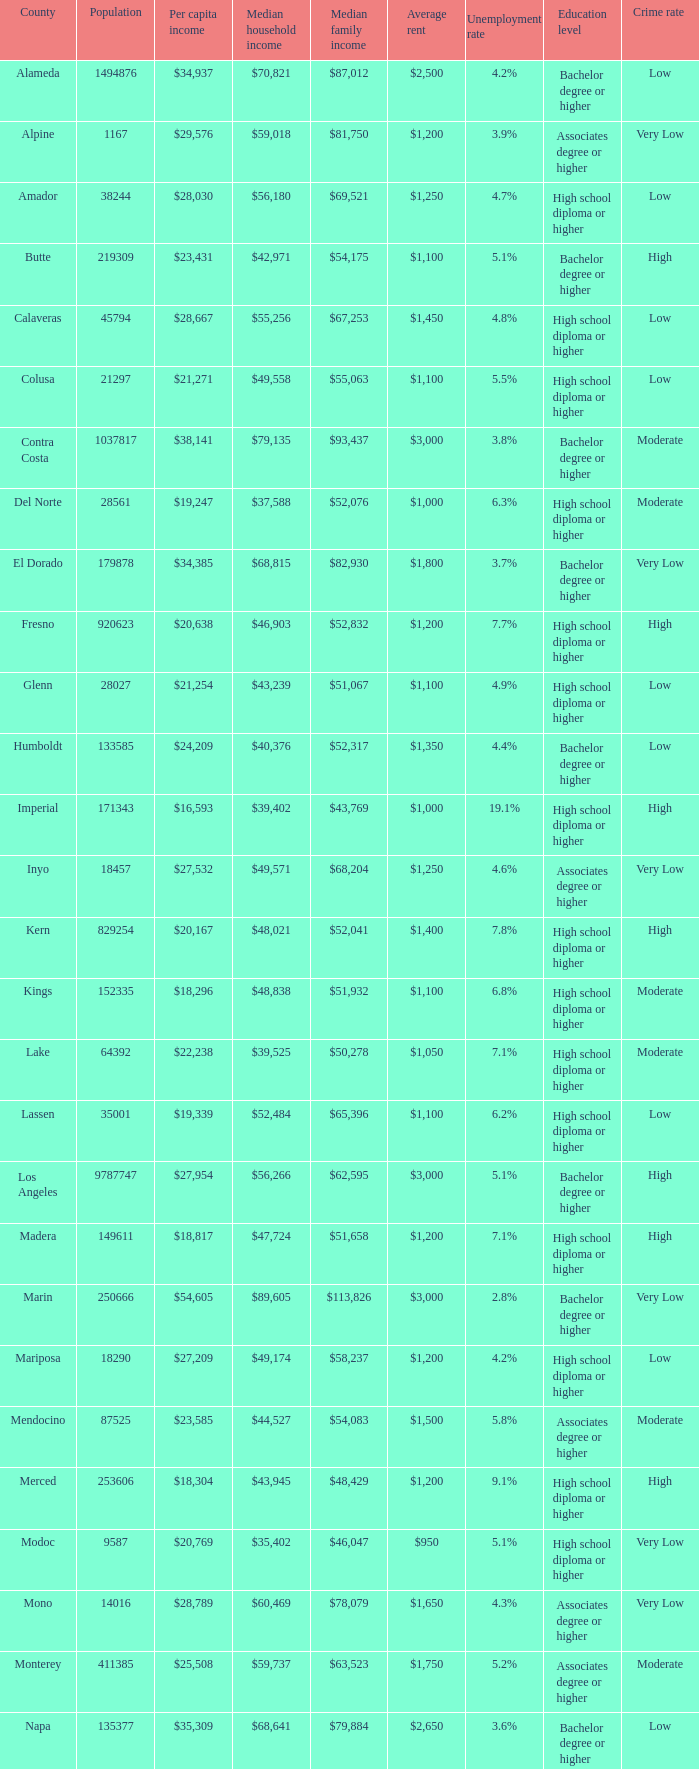In sacramento, what is the middle household income? $56,553. 